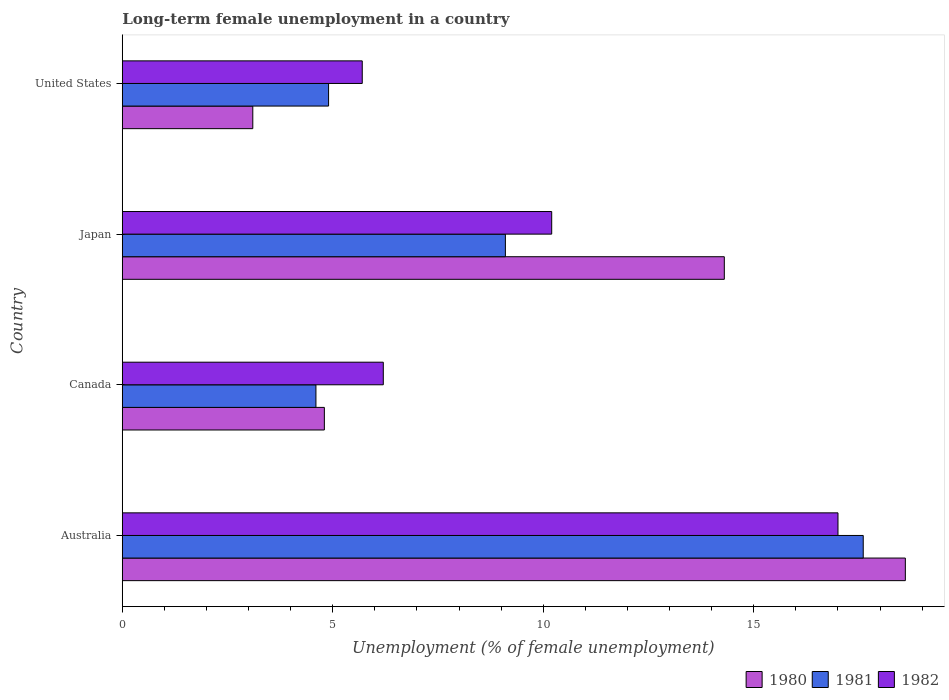How many different coloured bars are there?
Ensure brevity in your answer.  3. How many groups of bars are there?
Your response must be concise. 4. Are the number of bars on each tick of the Y-axis equal?
Offer a terse response. Yes. How many bars are there on the 2nd tick from the top?
Make the answer very short. 3. What is the label of the 1st group of bars from the top?
Give a very brief answer. United States. In how many cases, is the number of bars for a given country not equal to the number of legend labels?
Give a very brief answer. 0. What is the percentage of long-term unemployed female population in 1980 in Japan?
Provide a succinct answer. 14.3. Across all countries, what is the maximum percentage of long-term unemployed female population in 1981?
Make the answer very short. 17.6. Across all countries, what is the minimum percentage of long-term unemployed female population in 1982?
Ensure brevity in your answer.  5.7. What is the total percentage of long-term unemployed female population in 1981 in the graph?
Give a very brief answer. 36.2. What is the difference between the percentage of long-term unemployed female population in 1981 in Australia and that in Canada?
Offer a terse response. 13. What is the difference between the percentage of long-term unemployed female population in 1982 in Japan and the percentage of long-term unemployed female population in 1980 in Canada?
Ensure brevity in your answer.  5.4. What is the average percentage of long-term unemployed female population in 1981 per country?
Give a very brief answer. 9.05. What is the difference between the percentage of long-term unemployed female population in 1982 and percentage of long-term unemployed female population in 1980 in Canada?
Ensure brevity in your answer.  1.4. In how many countries, is the percentage of long-term unemployed female population in 1980 greater than 9 %?
Your answer should be very brief. 2. What is the ratio of the percentage of long-term unemployed female population in 1981 in Japan to that in United States?
Make the answer very short. 1.86. Is the difference between the percentage of long-term unemployed female population in 1982 in Japan and United States greater than the difference between the percentage of long-term unemployed female population in 1980 in Japan and United States?
Your answer should be very brief. No. What is the difference between the highest and the second highest percentage of long-term unemployed female population in 1980?
Give a very brief answer. 4.3. What is the difference between the highest and the lowest percentage of long-term unemployed female population in 1982?
Offer a terse response. 11.3. Is it the case that in every country, the sum of the percentage of long-term unemployed female population in 1980 and percentage of long-term unemployed female population in 1982 is greater than the percentage of long-term unemployed female population in 1981?
Your answer should be compact. Yes. Are all the bars in the graph horizontal?
Offer a very short reply. Yes. Are the values on the major ticks of X-axis written in scientific E-notation?
Your response must be concise. No. Where does the legend appear in the graph?
Make the answer very short. Bottom right. How many legend labels are there?
Offer a very short reply. 3. What is the title of the graph?
Offer a very short reply. Long-term female unemployment in a country. Does "1984" appear as one of the legend labels in the graph?
Ensure brevity in your answer.  No. What is the label or title of the X-axis?
Your answer should be compact. Unemployment (% of female unemployment). What is the label or title of the Y-axis?
Provide a succinct answer. Country. What is the Unemployment (% of female unemployment) of 1980 in Australia?
Provide a short and direct response. 18.6. What is the Unemployment (% of female unemployment) in 1981 in Australia?
Make the answer very short. 17.6. What is the Unemployment (% of female unemployment) of 1982 in Australia?
Provide a succinct answer. 17. What is the Unemployment (% of female unemployment) in 1980 in Canada?
Your answer should be very brief. 4.8. What is the Unemployment (% of female unemployment) of 1981 in Canada?
Offer a terse response. 4.6. What is the Unemployment (% of female unemployment) of 1982 in Canada?
Offer a very short reply. 6.2. What is the Unemployment (% of female unemployment) of 1980 in Japan?
Offer a very short reply. 14.3. What is the Unemployment (% of female unemployment) of 1981 in Japan?
Provide a succinct answer. 9.1. What is the Unemployment (% of female unemployment) of 1982 in Japan?
Ensure brevity in your answer.  10.2. What is the Unemployment (% of female unemployment) of 1980 in United States?
Provide a short and direct response. 3.1. What is the Unemployment (% of female unemployment) of 1981 in United States?
Offer a very short reply. 4.9. What is the Unemployment (% of female unemployment) of 1982 in United States?
Keep it short and to the point. 5.7. Across all countries, what is the maximum Unemployment (% of female unemployment) in 1980?
Keep it short and to the point. 18.6. Across all countries, what is the maximum Unemployment (% of female unemployment) in 1981?
Offer a terse response. 17.6. Across all countries, what is the maximum Unemployment (% of female unemployment) of 1982?
Provide a succinct answer. 17. Across all countries, what is the minimum Unemployment (% of female unemployment) of 1980?
Your answer should be very brief. 3.1. Across all countries, what is the minimum Unemployment (% of female unemployment) in 1981?
Keep it short and to the point. 4.6. Across all countries, what is the minimum Unemployment (% of female unemployment) in 1982?
Your response must be concise. 5.7. What is the total Unemployment (% of female unemployment) of 1980 in the graph?
Provide a short and direct response. 40.8. What is the total Unemployment (% of female unemployment) in 1981 in the graph?
Ensure brevity in your answer.  36.2. What is the total Unemployment (% of female unemployment) of 1982 in the graph?
Your response must be concise. 39.1. What is the difference between the Unemployment (% of female unemployment) of 1982 in Australia and that in Canada?
Give a very brief answer. 10.8. What is the difference between the Unemployment (% of female unemployment) in 1981 in Australia and that in United States?
Give a very brief answer. 12.7. What is the difference between the Unemployment (% of female unemployment) of 1982 in Australia and that in United States?
Keep it short and to the point. 11.3. What is the difference between the Unemployment (% of female unemployment) in 1980 in Canada and that in Japan?
Ensure brevity in your answer.  -9.5. What is the difference between the Unemployment (% of female unemployment) in 1980 in Canada and that in United States?
Your answer should be compact. 1.7. What is the difference between the Unemployment (% of female unemployment) in 1982 in Canada and that in United States?
Offer a very short reply. 0.5. What is the difference between the Unemployment (% of female unemployment) in 1980 in Japan and that in United States?
Provide a succinct answer. 11.2. What is the difference between the Unemployment (% of female unemployment) in 1982 in Japan and that in United States?
Keep it short and to the point. 4.5. What is the difference between the Unemployment (% of female unemployment) of 1981 in Australia and the Unemployment (% of female unemployment) of 1982 in Canada?
Ensure brevity in your answer.  11.4. What is the difference between the Unemployment (% of female unemployment) of 1980 in Australia and the Unemployment (% of female unemployment) of 1981 in Japan?
Your answer should be compact. 9.5. What is the difference between the Unemployment (% of female unemployment) in 1980 in Australia and the Unemployment (% of female unemployment) in 1981 in United States?
Give a very brief answer. 13.7. What is the difference between the Unemployment (% of female unemployment) of 1981 in Australia and the Unemployment (% of female unemployment) of 1982 in United States?
Make the answer very short. 11.9. What is the difference between the Unemployment (% of female unemployment) in 1980 in Canada and the Unemployment (% of female unemployment) in 1981 in Japan?
Your answer should be very brief. -4.3. What is the difference between the Unemployment (% of female unemployment) of 1980 in Canada and the Unemployment (% of female unemployment) of 1982 in Japan?
Ensure brevity in your answer.  -5.4. What is the difference between the Unemployment (% of female unemployment) of 1981 in Canada and the Unemployment (% of female unemployment) of 1982 in United States?
Give a very brief answer. -1.1. What is the difference between the Unemployment (% of female unemployment) of 1980 in Japan and the Unemployment (% of female unemployment) of 1982 in United States?
Ensure brevity in your answer.  8.6. What is the average Unemployment (% of female unemployment) in 1980 per country?
Provide a short and direct response. 10.2. What is the average Unemployment (% of female unemployment) of 1981 per country?
Your response must be concise. 9.05. What is the average Unemployment (% of female unemployment) of 1982 per country?
Your answer should be very brief. 9.78. What is the difference between the Unemployment (% of female unemployment) of 1980 and Unemployment (% of female unemployment) of 1982 in Australia?
Your answer should be very brief. 1.6. What is the difference between the Unemployment (% of female unemployment) of 1981 and Unemployment (% of female unemployment) of 1982 in Australia?
Your answer should be compact. 0.6. What is the difference between the Unemployment (% of female unemployment) of 1980 and Unemployment (% of female unemployment) of 1982 in Canada?
Keep it short and to the point. -1.4. What is the difference between the Unemployment (% of female unemployment) in 1981 and Unemployment (% of female unemployment) in 1982 in Canada?
Your response must be concise. -1.6. What is the difference between the Unemployment (% of female unemployment) of 1980 and Unemployment (% of female unemployment) of 1981 in Japan?
Provide a short and direct response. 5.2. What is the difference between the Unemployment (% of female unemployment) of 1980 and Unemployment (% of female unemployment) of 1982 in Japan?
Give a very brief answer. 4.1. What is the difference between the Unemployment (% of female unemployment) of 1980 and Unemployment (% of female unemployment) of 1982 in United States?
Offer a terse response. -2.6. What is the ratio of the Unemployment (% of female unemployment) of 1980 in Australia to that in Canada?
Your answer should be compact. 3.88. What is the ratio of the Unemployment (% of female unemployment) in 1981 in Australia to that in Canada?
Ensure brevity in your answer.  3.83. What is the ratio of the Unemployment (% of female unemployment) in 1982 in Australia to that in Canada?
Provide a short and direct response. 2.74. What is the ratio of the Unemployment (% of female unemployment) of 1980 in Australia to that in Japan?
Your answer should be compact. 1.3. What is the ratio of the Unemployment (% of female unemployment) in 1981 in Australia to that in Japan?
Keep it short and to the point. 1.93. What is the ratio of the Unemployment (% of female unemployment) in 1981 in Australia to that in United States?
Provide a short and direct response. 3.59. What is the ratio of the Unemployment (% of female unemployment) of 1982 in Australia to that in United States?
Offer a terse response. 2.98. What is the ratio of the Unemployment (% of female unemployment) in 1980 in Canada to that in Japan?
Give a very brief answer. 0.34. What is the ratio of the Unemployment (% of female unemployment) in 1981 in Canada to that in Japan?
Give a very brief answer. 0.51. What is the ratio of the Unemployment (% of female unemployment) in 1982 in Canada to that in Japan?
Offer a terse response. 0.61. What is the ratio of the Unemployment (% of female unemployment) in 1980 in Canada to that in United States?
Offer a very short reply. 1.55. What is the ratio of the Unemployment (% of female unemployment) in 1981 in Canada to that in United States?
Ensure brevity in your answer.  0.94. What is the ratio of the Unemployment (% of female unemployment) in 1982 in Canada to that in United States?
Make the answer very short. 1.09. What is the ratio of the Unemployment (% of female unemployment) of 1980 in Japan to that in United States?
Offer a very short reply. 4.61. What is the ratio of the Unemployment (% of female unemployment) in 1981 in Japan to that in United States?
Offer a terse response. 1.86. What is the ratio of the Unemployment (% of female unemployment) in 1982 in Japan to that in United States?
Keep it short and to the point. 1.79. What is the difference between the highest and the second highest Unemployment (% of female unemployment) in 1980?
Provide a succinct answer. 4.3. What is the difference between the highest and the second highest Unemployment (% of female unemployment) in 1981?
Give a very brief answer. 8.5. What is the difference between the highest and the second highest Unemployment (% of female unemployment) in 1982?
Give a very brief answer. 6.8. What is the difference between the highest and the lowest Unemployment (% of female unemployment) in 1980?
Offer a very short reply. 15.5. What is the difference between the highest and the lowest Unemployment (% of female unemployment) in 1981?
Make the answer very short. 13. What is the difference between the highest and the lowest Unemployment (% of female unemployment) of 1982?
Provide a succinct answer. 11.3. 